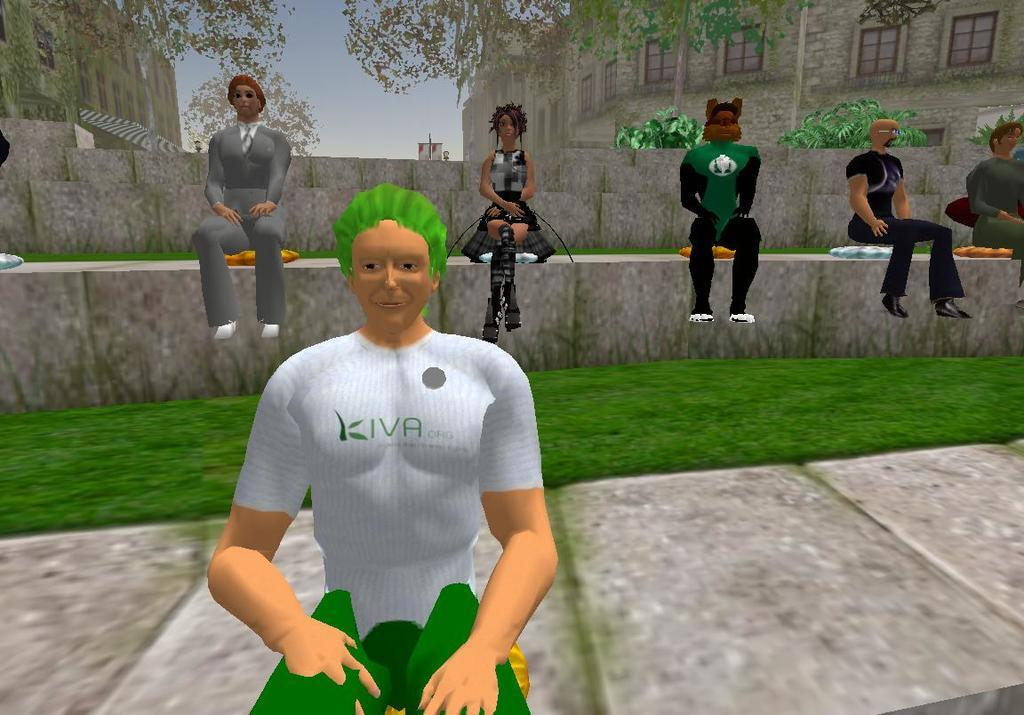What is happening in the image involving persons? There is an animation of persons in the image. What type of environment is depicted in the image? There is a grassy land and many trees in the image. Can you describe any structures in the image? There is a building in the image. What type of reward is being given to the persons in the image? There is no indication of a reward being given in the image; it only shows an animation of persons. What act are the persons performing in the image? The image only shows an animation of persons, but it does not specify any particular act they are performing. 